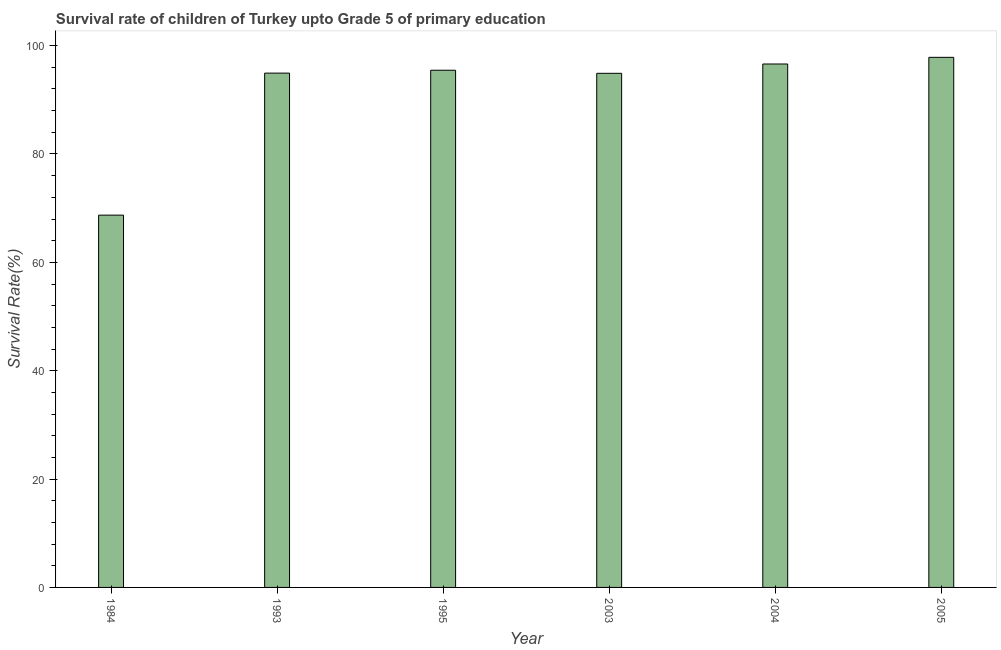What is the title of the graph?
Offer a very short reply. Survival rate of children of Turkey upto Grade 5 of primary education. What is the label or title of the Y-axis?
Provide a succinct answer. Survival Rate(%). What is the survival rate in 1993?
Ensure brevity in your answer.  94.93. Across all years, what is the maximum survival rate?
Your answer should be very brief. 97.84. Across all years, what is the minimum survival rate?
Provide a short and direct response. 68.72. In which year was the survival rate minimum?
Keep it short and to the point. 1984. What is the sum of the survival rate?
Offer a very short reply. 548.45. What is the difference between the survival rate in 2003 and 2005?
Provide a succinct answer. -2.95. What is the average survival rate per year?
Keep it short and to the point. 91.41. What is the median survival rate?
Ensure brevity in your answer.  95.19. In how many years, is the survival rate greater than 64 %?
Give a very brief answer. 6. Do a majority of the years between 2003 and 2005 (inclusive) have survival rate greater than 64 %?
Give a very brief answer. Yes. What is the ratio of the survival rate in 1995 to that in 2003?
Offer a very short reply. 1.01. Is the difference between the survival rate in 2003 and 2004 greater than the difference between any two years?
Your answer should be compact. No. What is the difference between the highest and the second highest survival rate?
Provide a succinct answer. 1.23. What is the difference between the highest and the lowest survival rate?
Provide a short and direct response. 29.13. In how many years, is the survival rate greater than the average survival rate taken over all years?
Provide a succinct answer. 5. How many bars are there?
Offer a very short reply. 6. Are all the bars in the graph horizontal?
Provide a short and direct response. No. What is the Survival Rate(%) of 1984?
Give a very brief answer. 68.72. What is the Survival Rate(%) in 1993?
Offer a very short reply. 94.93. What is the Survival Rate(%) in 1995?
Your answer should be very brief. 95.46. What is the Survival Rate(%) in 2003?
Give a very brief answer. 94.89. What is the Survival Rate(%) of 2004?
Offer a terse response. 96.61. What is the Survival Rate(%) of 2005?
Provide a short and direct response. 97.84. What is the difference between the Survival Rate(%) in 1984 and 1993?
Make the answer very short. -26.21. What is the difference between the Survival Rate(%) in 1984 and 1995?
Give a very brief answer. -26.74. What is the difference between the Survival Rate(%) in 1984 and 2003?
Give a very brief answer. -26.17. What is the difference between the Survival Rate(%) in 1984 and 2004?
Ensure brevity in your answer.  -27.9. What is the difference between the Survival Rate(%) in 1984 and 2005?
Your answer should be compact. -29.13. What is the difference between the Survival Rate(%) in 1993 and 1995?
Keep it short and to the point. -0.53. What is the difference between the Survival Rate(%) in 1993 and 2003?
Provide a succinct answer. 0.04. What is the difference between the Survival Rate(%) in 1993 and 2004?
Give a very brief answer. -1.69. What is the difference between the Survival Rate(%) in 1993 and 2005?
Provide a short and direct response. -2.91. What is the difference between the Survival Rate(%) in 1995 and 2003?
Ensure brevity in your answer.  0.57. What is the difference between the Survival Rate(%) in 1995 and 2004?
Your answer should be very brief. -1.15. What is the difference between the Survival Rate(%) in 1995 and 2005?
Offer a terse response. -2.38. What is the difference between the Survival Rate(%) in 2003 and 2004?
Keep it short and to the point. -1.72. What is the difference between the Survival Rate(%) in 2003 and 2005?
Give a very brief answer. -2.95. What is the difference between the Survival Rate(%) in 2004 and 2005?
Your answer should be compact. -1.23. What is the ratio of the Survival Rate(%) in 1984 to that in 1993?
Offer a very short reply. 0.72. What is the ratio of the Survival Rate(%) in 1984 to that in 1995?
Offer a terse response. 0.72. What is the ratio of the Survival Rate(%) in 1984 to that in 2003?
Make the answer very short. 0.72. What is the ratio of the Survival Rate(%) in 1984 to that in 2004?
Make the answer very short. 0.71. What is the ratio of the Survival Rate(%) in 1984 to that in 2005?
Make the answer very short. 0.7. What is the ratio of the Survival Rate(%) in 1993 to that in 1995?
Offer a terse response. 0.99. What is the ratio of the Survival Rate(%) in 1993 to that in 2003?
Give a very brief answer. 1. What is the ratio of the Survival Rate(%) in 1993 to that in 2004?
Offer a very short reply. 0.98. 